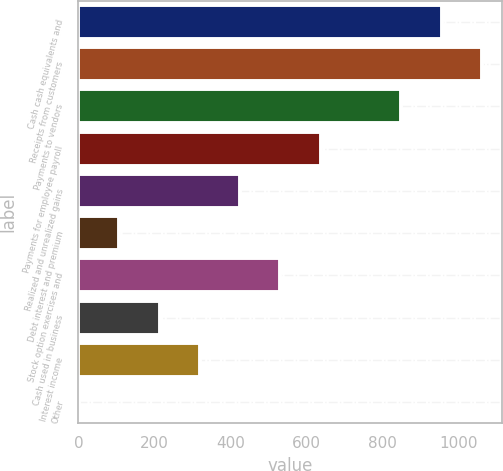Convert chart. <chart><loc_0><loc_0><loc_500><loc_500><bar_chart><fcel>Cash cash equivalents and<fcel>Receipts from customers<fcel>Payments to vendors<fcel>Payments for employee payroll<fcel>Realized and unrealized gains<fcel>Debt interest and premium<fcel>Stock option exercises and<fcel>Cash used in business<fcel>Interest income<fcel>Other<nl><fcel>955.51<fcel>1061.5<fcel>849.52<fcel>637.54<fcel>425.56<fcel>107.59<fcel>531.55<fcel>213.58<fcel>319.57<fcel>1.6<nl></chart> 